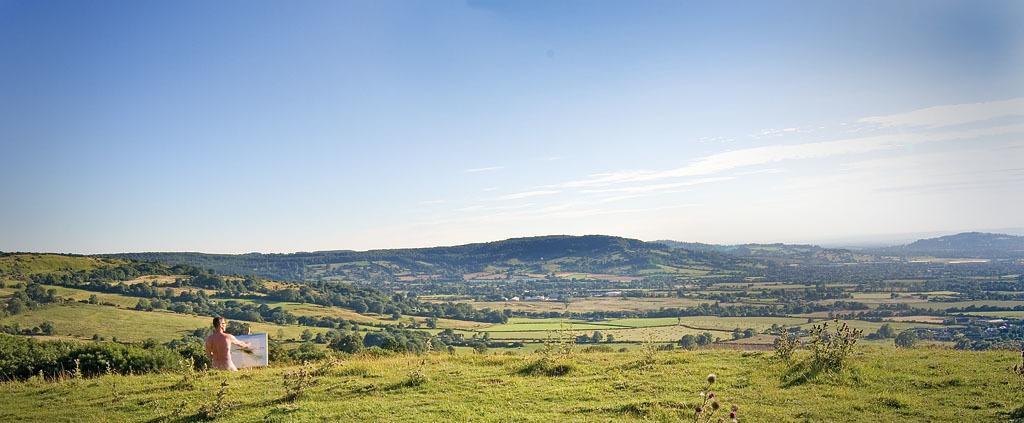How would you summarize this image in a sentence or two? In this image we can see few hills. There are many trees and plants in the image. There is a grassy land in the image. There is a sky in the image. There is a person and he is holding some objects in his hand. 